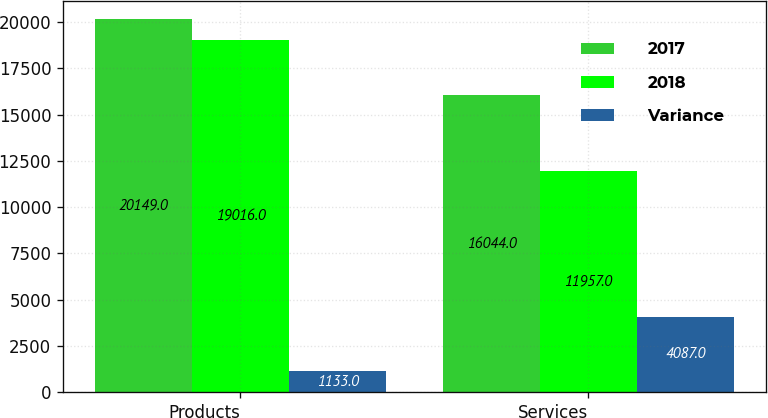Convert chart. <chart><loc_0><loc_0><loc_500><loc_500><stacked_bar_chart><ecel><fcel>Products<fcel>Services<nl><fcel>2017<fcel>20149<fcel>16044<nl><fcel>2018<fcel>19016<fcel>11957<nl><fcel>Variance<fcel>1133<fcel>4087<nl></chart> 